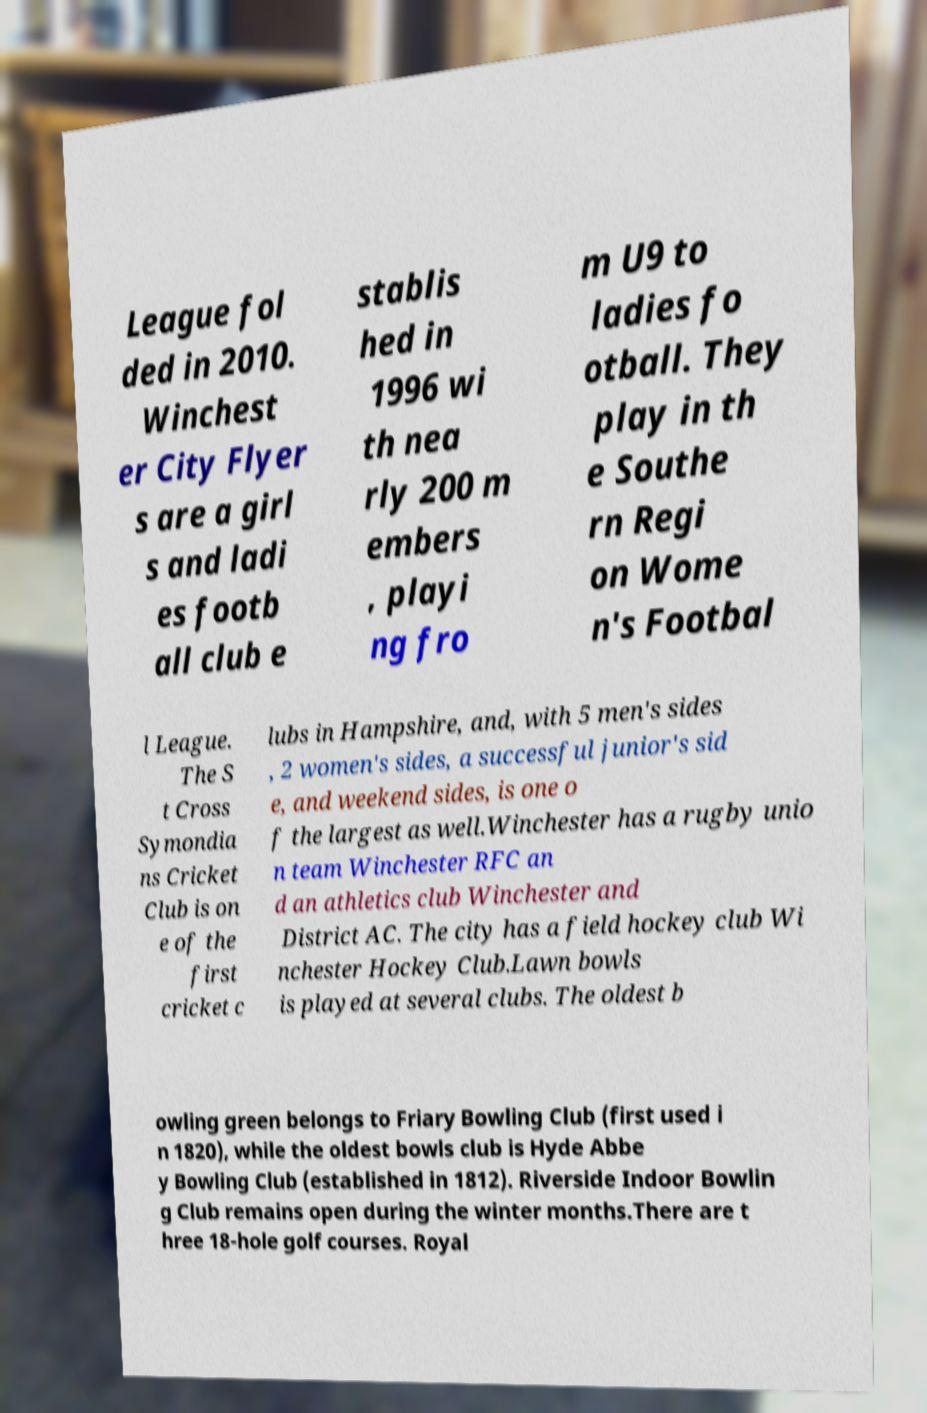Could you assist in decoding the text presented in this image and type it out clearly? League fol ded in 2010. Winchest er City Flyer s are a girl s and ladi es footb all club e stablis hed in 1996 wi th nea rly 200 m embers , playi ng fro m U9 to ladies fo otball. They play in th e Southe rn Regi on Wome n's Footbal l League. The S t Cross Symondia ns Cricket Club is on e of the first cricket c lubs in Hampshire, and, with 5 men's sides , 2 women's sides, a successful junior's sid e, and weekend sides, is one o f the largest as well.Winchester has a rugby unio n team Winchester RFC an d an athletics club Winchester and District AC. The city has a field hockey club Wi nchester Hockey Club.Lawn bowls is played at several clubs. The oldest b owling green belongs to Friary Bowling Club (first used i n 1820), while the oldest bowls club is Hyde Abbe y Bowling Club (established in 1812). Riverside Indoor Bowlin g Club remains open during the winter months.There are t hree 18-hole golf courses. Royal 